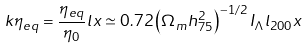Convert formula to latex. <formula><loc_0><loc_0><loc_500><loc_500>k \eta _ { e q } = \frac { \eta _ { e q } } { \eta _ { 0 } } l x \simeq 0 . 7 2 \left ( \Omega _ { m } h _ { 7 5 } ^ { 2 } \right ) ^ { - 1 / 2 } I _ { \Lambda } l _ { 2 0 0 } x</formula> 